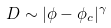Convert formula to latex. <formula><loc_0><loc_0><loc_500><loc_500>D \sim | \phi - \phi _ { c } | ^ { \gamma }</formula> 